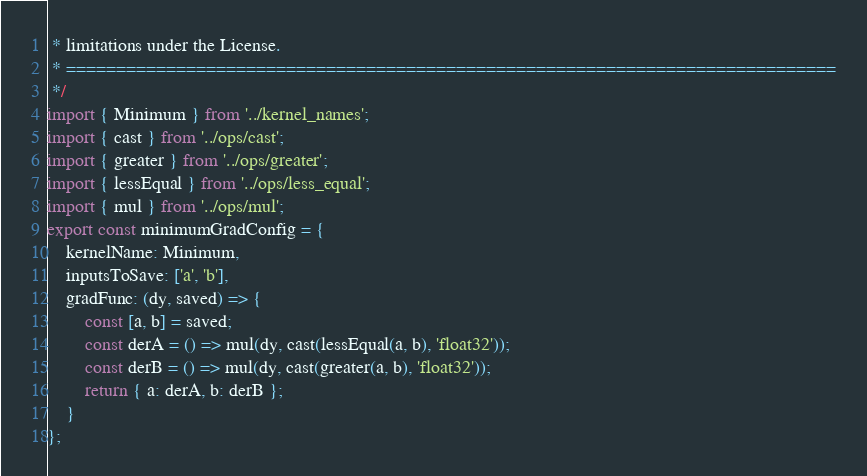<code> <loc_0><loc_0><loc_500><loc_500><_JavaScript_> * limitations under the License.
 * =============================================================================
 */
import { Minimum } from '../kernel_names';
import { cast } from '../ops/cast';
import { greater } from '../ops/greater';
import { lessEqual } from '../ops/less_equal';
import { mul } from '../ops/mul';
export const minimumGradConfig = {
    kernelName: Minimum,
    inputsToSave: ['a', 'b'],
    gradFunc: (dy, saved) => {
        const [a, b] = saved;
        const derA = () => mul(dy, cast(lessEqual(a, b), 'float32'));
        const derB = () => mul(dy, cast(greater(a, b), 'float32'));
        return { a: derA, b: derB };
    }
};</code> 